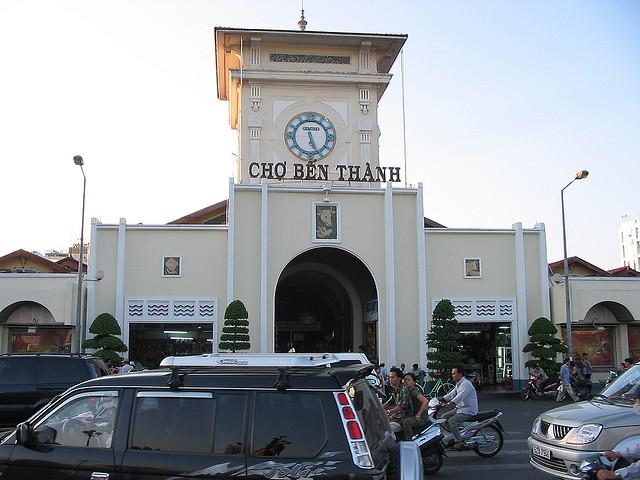Judging from the signage beneath the clock where is this structure located?

Choices:
A) india
B) south america
C) europe
D) asia asia 